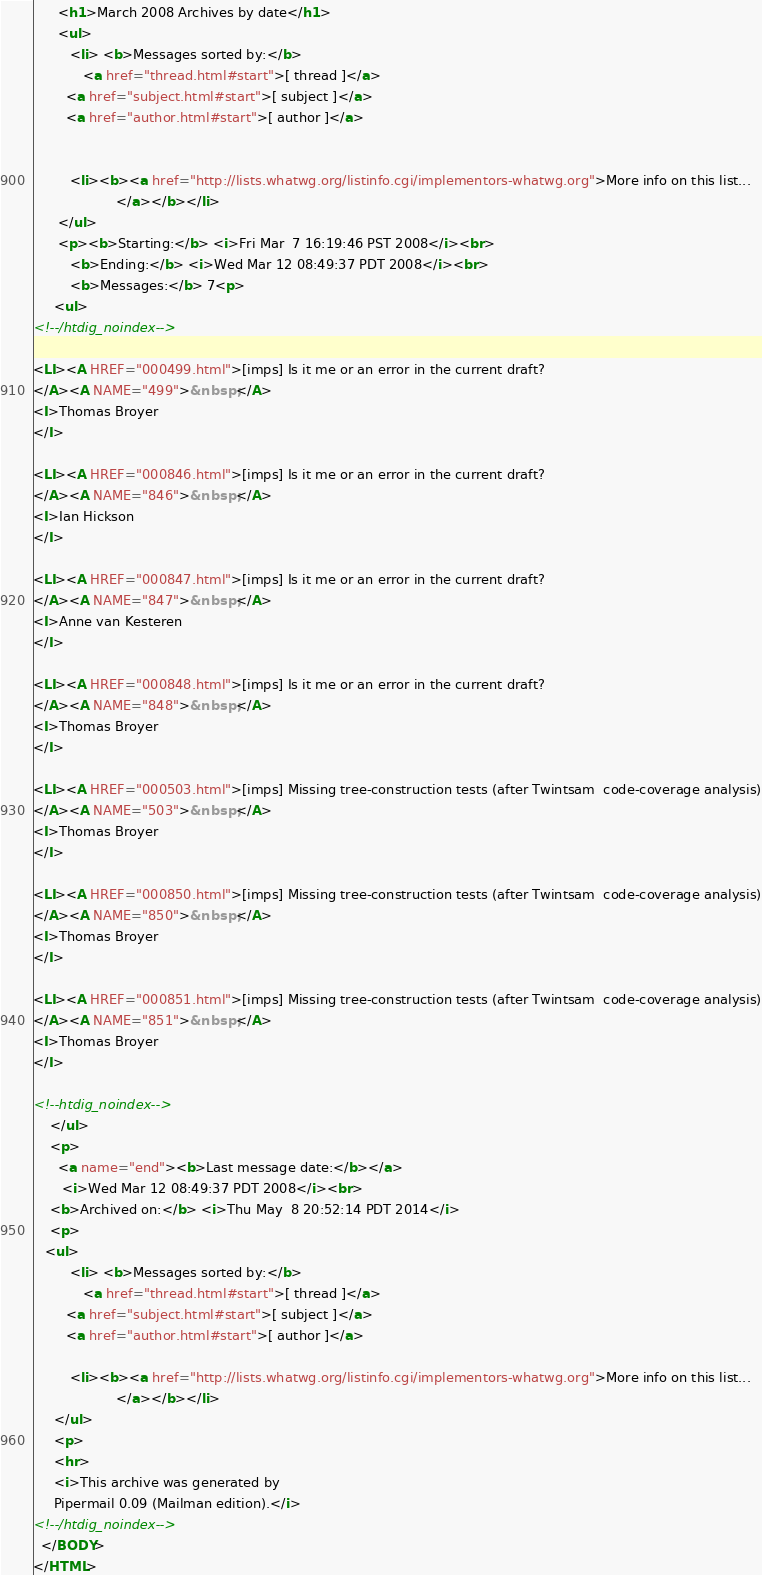<code> <loc_0><loc_0><loc_500><loc_500><_HTML_>      <h1>March 2008 Archives by date</h1>
      <ul>
         <li> <b>Messages sorted by:</b>
	        <a href="thread.html#start">[ thread ]</a>
		<a href="subject.html#start">[ subject ]</a>
		<a href="author.html#start">[ author ]</a>
		

	     <li><b><a href="http://lists.whatwg.org/listinfo.cgi/implementors-whatwg.org">More info on this list...
                    </a></b></li>
      </ul>
      <p><b>Starting:</b> <i>Fri Mar  7 16:19:46 PST 2008</i><br>
         <b>Ending:</b> <i>Wed Mar 12 08:49:37 PDT 2008</i><br>
         <b>Messages:</b> 7<p>
     <ul>
<!--/htdig_noindex-->

<LI><A HREF="000499.html">[imps] Is it me or an error in the current draft?
</A><A NAME="499">&nbsp;</A>
<I>Thomas Broyer
</I>

<LI><A HREF="000846.html">[imps] Is it me or an error in the current draft?
</A><A NAME="846">&nbsp;</A>
<I>Ian Hickson
</I>

<LI><A HREF="000847.html">[imps] Is it me or an error in the current draft?
</A><A NAME="847">&nbsp;</A>
<I>Anne van Kesteren
</I>

<LI><A HREF="000848.html">[imps] Is it me or an error in the current draft?
</A><A NAME="848">&nbsp;</A>
<I>Thomas Broyer
</I>

<LI><A HREF="000503.html">[imps] Missing tree-construction tests (after Twintsam	code-coverage analysis)
</A><A NAME="503">&nbsp;</A>
<I>Thomas Broyer
</I>

<LI><A HREF="000850.html">[imps] Missing tree-construction tests (after Twintsam	code-coverage analysis)
</A><A NAME="850">&nbsp;</A>
<I>Thomas Broyer
</I>

<LI><A HREF="000851.html">[imps] Missing tree-construction tests (after Twintsam	code-coverage analysis)
</A><A NAME="851">&nbsp;</A>
<I>Thomas Broyer
</I>

<!--htdig_noindex-->
	</ul>
    <p>
      <a name="end"><b>Last message date:</b></a> 
       <i>Wed Mar 12 08:49:37 PDT 2008</i><br>
    <b>Archived on:</b> <i>Thu May  8 20:52:14 PDT 2014</i>
    <p>
   <ul>
         <li> <b>Messages sorted by:</b>
	        <a href="thread.html#start">[ thread ]</a>
		<a href="subject.html#start">[ subject ]</a>
		<a href="author.html#start">[ author ]</a>
		
	     <li><b><a href="http://lists.whatwg.org/listinfo.cgi/implementors-whatwg.org">More info on this list...
                    </a></b></li>
     </ul>
     <p>
     <hr>
     <i>This archive was generated by
     Pipermail 0.09 (Mailman edition).</i>
<!--/htdig_noindex-->
  </BODY>
</HTML>

</code> 